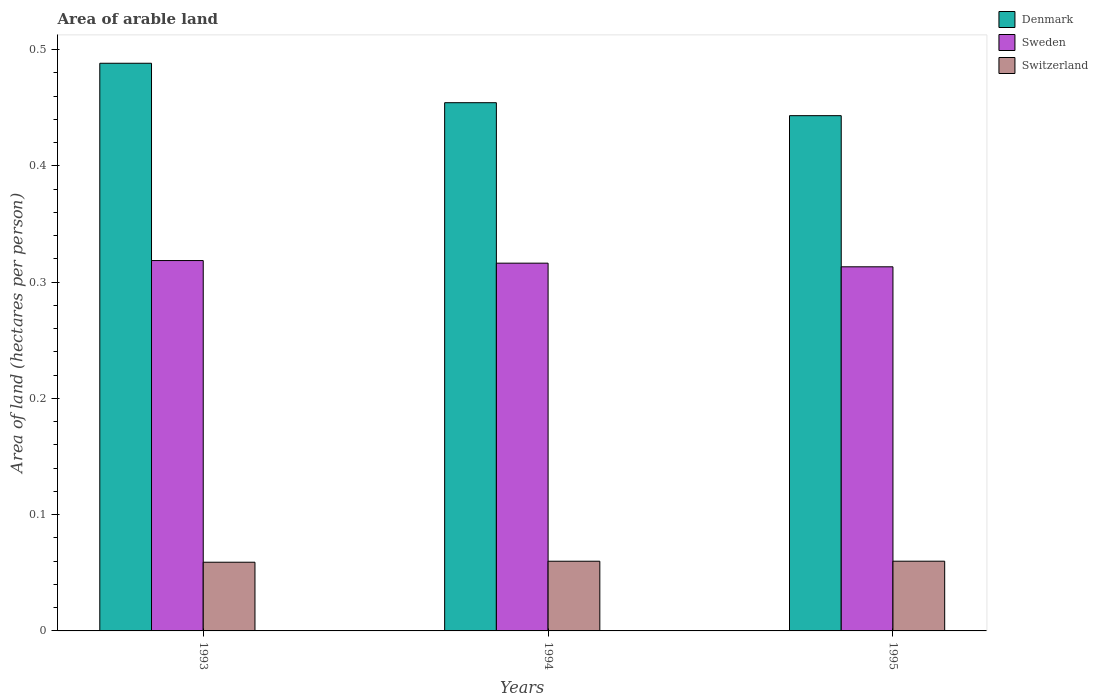How many different coloured bars are there?
Offer a terse response. 3. How many bars are there on the 1st tick from the left?
Your answer should be very brief. 3. How many bars are there on the 2nd tick from the right?
Provide a succinct answer. 3. What is the label of the 3rd group of bars from the left?
Your answer should be compact. 1995. What is the total arable land in Sweden in 1995?
Keep it short and to the point. 0.31. Across all years, what is the maximum total arable land in Switzerland?
Your answer should be very brief. 0.06. Across all years, what is the minimum total arable land in Sweden?
Provide a short and direct response. 0.31. In which year was the total arable land in Switzerland maximum?
Ensure brevity in your answer.  1995. What is the total total arable land in Switzerland in the graph?
Offer a very short reply. 0.18. What is the difference between the total arable land in Sweden in 1993 and that in 1994?
Offer a terse response. 0. What is the difference between the total arable land in Switzerland in 1993 and the total arable land in Denmark in 1994?
Your answer should be compact. -0.4. What is the average total arable land in Denmark per year?
Your answer should be very brief. 0.46. In the year 1994, what is the difference between the total arable land in Switzerland and total arable land in Denmark?
Your answer should be compact. -0.39. In how many years, is the total arable land in Denmark greater than 0.2 hectares per person?
Provide a succinct answer. 3. What is the ratio of the total arable land in Switzerland in 1993 to that in 1995?
Give a very brief answer. 0.99. Is the total arable land in Switzerland in 1994 less than that in 1995?
Offer a very short reply. Yes. Is the difference between the total arable land in Switzerland in 1993 and 1994 greater than the difference between the total arable land in Denmark in 1993 and 1994?
Give a very brief answer. No. What is the difference between the highest and the second highest total arable land in Switzerland?
Ensure brevity in your answer.  2.689334764650192e-5. What is the difference between the highest and the lowest total arable land in Denmark?
Keep it short and to the point. 0.05. What does the 3rd bar from the right in 1993 represents?
Your answer should be compact. Denmark. How many bars are there?
Provide a short and direct response. 9. Are all the bars in the graph horizontal?
Offer a terse response. No. What is the difference between two consecutive major ticks on the Y-axis?
Ensure brevity in your answer.  0.1. Does the graph contain any zero values?
Your answer should be very brief. No. How are the legend labels stacked?
Give a very brief answer. Vertical. What is the title of the graph?
Provide a short and direct response. Area of arable land. Does "Yemen, Rep." appear as one of the legend labels in the graph?
Give a very brief answer. No. What is the label or title of the X-axis?
Offer a very short reply. Years. What is the label or title of the Y-axis?
Offer a terse response. Area of land (hectares per person). What is the Area of land (hectares per person) of Denmark in 1993?
Provide a succinct answer. 0.49. What is the Area of land (hectares per person) of Sweden in 1993?
Offer a very short reply. 0.32. What is the Area of land (hectares per person) in Switzerland in 1993?
Provide a short and direct response. 0.06. What is the Area of land (hectares per person) in Denmark in 1994?
Make the answer very short. 0.45. What is the Area of land (hectares per person) in Sweden in 1994?
Your response must be concise. 0.32. What is the Area of land (hectares per person) in Switzerland in 1994?
Keep it short and to the point. 0.06. What is the Area of land (hectares per person) in Denmark in 1995?
Offer a very short reply. 0.44. What is the Area of land (hectares per person) in Sweden in 1995?
Ensure brevity in your answer.  0.31. What is the Area of land (hectares per person) in Switzerland in 1995?
Provide a short and direct response. 0.06. Across all years, what is the maximum Area of land (hectares per person) of Denmark?
Your response must be concise. 0.49. Across all years, what is the maximum Area of land (hectares per person) in Sweden?
Your response must be concise. 0.32. Across all years, what is the maximum Area of land (hectares per person) of Switzerland?
Your response must be concise. 0.06. Across all years, what is the minimum Area of land (hectares per person) in Denmark?
Keep it short and to the point. 0.44. Across all years, what is the minimum Area of land (hectares per person) in Sweden?
Keep it short and to the point. 0.31. Across all years, what is the minimum Area of land (hectares per person) in Switzerland?
Ensure brevity in your answer.  0.06. What is the total Area of land (hectares per person) of Denmark in the graph?
Ensure brevity in your answer.  1.39. What is the total Area of land (hectares per person) of Sweden in the graph?
Offer a very short reply. 0.95. What is the total Area of land (hectares per person) of Switzerland in the graph?
Keep it short and to the point. 0.18. What is the difference between the Area of land (hectares per person) in Denmark in 1993 and that in 1994?
Your answer should be compact. 0.03. What is the difference between the Area of land (hectares per person) in Sweden in 1993 and that in 1994?
Your answer should be compact. 0. What is the difference between the Area of land (hectares per person) of Switzerland in 1993 and that in 1994?
Your response must be concise. -0. What is the difference between the Area of land (hectares per person) of Denmark in 1993 and that in 1995?
Provide a short and direct response. 0.05. What is the difference between the Area of land (hectares per person) of Sweden in 1993 and that in 1995?
Offer a terse response. 0.01. What is the difference between the Area of land (hectares per person) in Switzerland in 1993 and that in 1995?
Your response must be concise. -0. What is the difference between the Area of land (hectares per person) of Denmark in 1994 and that in 1995?
Make the answer very short. 0.01. What is the difference between the Area of land (hectares per person) of Sweden in 1994 and that in 1995?
Offer a very short reply. 0. What is the difference between the Area of land (hectares per person) in Denmark in 1993 and the Area of land (hectares per person) in Sweden in 1994?
Offer a terse response. 0.17. What is the difference between the Area of land (hectares per person) of Denmark in 1993 and the Area of land (hectares per person) of Switzerland in 1994?
Make the answer very short. 0.43. What is the difference between the Area of land (hectares per person) of Sweden in 1993 and the Area of land (hectares per person) of Switzerland in 1994?
Ensure brevity in your answer.  0.26. What is the difference between the Area of land (hectares per person) in Denmark in 1993 and the Area of land (hectares per person) in Sweden in 1995?
Give a very brief answer. 0.18. What is the difference between the Area of land (hectares per person) of Denmark in 1993 and the Area of land (hectares per person) of Switzerland in 1995?
Your answer should be compact. 0.43. What is the difference between the Area of land (hectares per person) of Sweden in 1993 and the Area of land (hectares per person) of Switzerland in 1995?
Give a very brief answer. 0.26. What is the difference between the Area of land (hectares per person) of Denmark in 1994 and the Area of land (hectares per person) of Sweden in 1995?
Offer a very short reply. 0.14. What is the difference between the Area of land (hectares per person) of Denmark in 1994 and the Area of land (hectares per person) of Switzerland in 1995?
Offer a very short reply. 0.39. What is the difference between the Area of land (hectares per person) of Sweden in 1994 and the Area of land (hectares per person) of Switzerland in 1995?
Provide a short and direct response. 0.26. What is the average Area of land (hectares per person) in Denmark per year?
Ensure brevity in your answer.  0.46. What is the average Area of land (hectares per person) in Sweden per year?
Provide a succinct answer. 0.32. What is the average Area of land (hectares per person) of Switzerland per year?
Make the answer very short. 0.06. In the year 1993, what is the difference between the Area of land (hectares per person) of Denmark and Area of land (hectares per person) of Sweden?
Ensure brevity in your answer.  0.17. In the year 1993, what is the difference between the Area of land (hectares per person) in Denmark and Area of land (hectares per person) in Switzerland?
Make the answer very short. 0.43. In the year 1993, what is the difference between the Area of land (hectares per person) of Sweden and Area of land (hectares per person) of Switzerland?
Your answer should be very brief. 0.26. In the year 1994, what is the difference between the Area of land (hectares per person) of Denmark and Area of land (hectares per person) of Sweden?
Keep it short and to the point. 0.14. In the year 1994, what is the difference between the Area of land (hectares per person) in Denmark and Area of land (hectares per person) in Switzerland?
Provide a succinct answer. 0.39. In the year 1994, what is the difference between the Area of land (hectares per person) of Sweden and Area of land (hectares per person) of Switzerland?
Your answer should be very brief. 0.26. In the year 1995, what is the difference between the Area of land (hectares per person) of Denmark and Area of land (hectares per person) of Sweden?
Your answer should be very brief. 0.13. In the year 1995, what is the difference between the Area of land (hectares per person) in Denmark and Area of land (hectares per person) in Switzerland?
Offer a terse response. 0.38. In the year 1995, what is the difference between the Area of land (hectares per person) in Sweden and Area of land (hectares per person) in Switzerland?
Your response must be concise. 0.25. What is the ratio of the Area of land (hectares per person) of Denmark in 1993 to that in 1994?
Provide a succinct answer. 1.07. What is the ratio of the Area of land (hectares per person) in Sweden in 1993 to that in 1994?
Give a very brief answer. 1.01. What is the ratio of the Area of land (hectares per person) in Switzerland in 1993 to that in 1994?
Your answer should be very brief. 0.99. What is the ratio of the Area of land (hectares per person) in Denmark in 1993 to that in 1995?
Provide a succinct answer. 1.1. What is the ratio of the Area of land (hectares per person) of Sweden in 1993 to that in 1995?
Your answer should be very brief. 1.02. What is the ratio of the Area of land (hectares per person) in Switzerland in 1993 to that in 1995?
Your response must be concise. 0.99. What is the ratio of the Area of land (hectares per person) in Denmark in 1994 to that in 1995?
Provide a succinct answer. 1.03. What is the ratio of the Area of land (hectares per person) in Sweden in 1994 to that in 1995?
Your answer should be very brief. 1.01. What is the difference between the highest and the second highest Area of land (hectares per person) in Denmark?
Offer a terse response. 0.03. What is the difference between the highest and the second highest Area of land (hectares per person) in Sweden?
Keep it short and to the point. 0. What is the difference between the highest and the second highest Area of land (hectares per person) of Switzerland?
Provide a succinct answer. 0. What is the difference between the highest and the lowest Area of land (hectares per person) of Denmark?
Give a very brief answer. 0.05. What is the difference between the highest and the lowest Area of land (hectares per person) of Sweden?
Give a very brief answer. 0.01. What is the difference between the highest and the lowest Area of land (hectares per person) of Switzerland?
Ensure brevity in your answer.  0. 